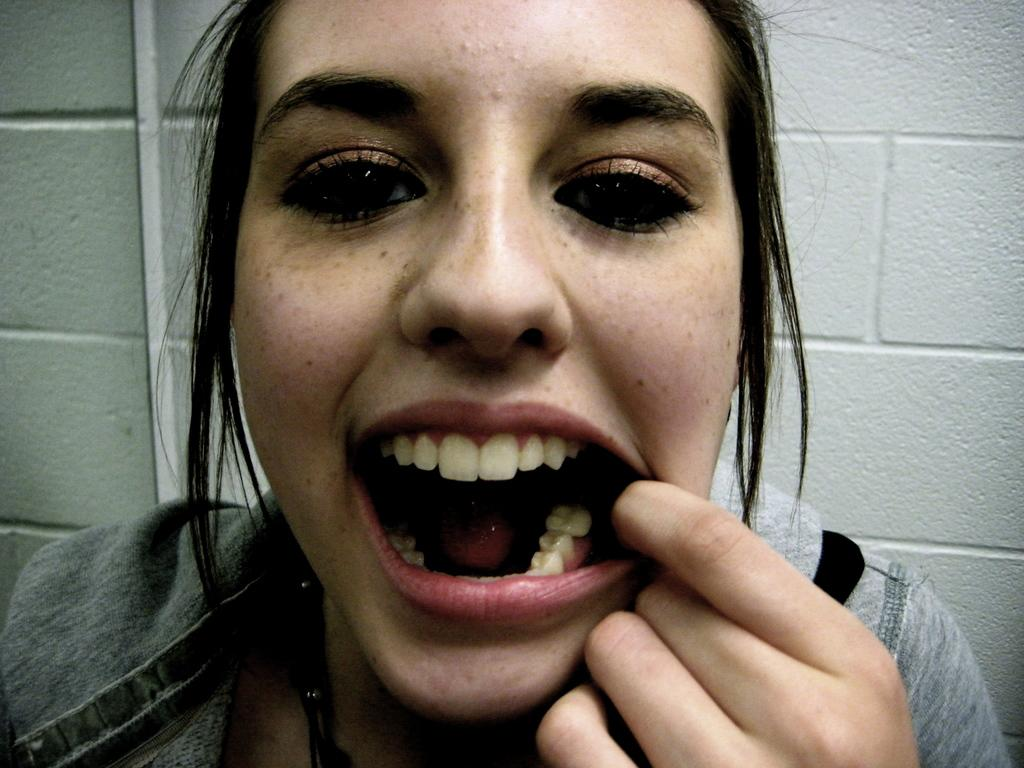Who is the main subject in the image? There is a lady in the image. What is the lady wearing in the image? The lady is wearing black threads. What type of accessory can be seen on the lady's neck? The lady has pearls on her neck. What is visible in the background of the image? There is a wall in the background of the image. What type of weather can be seen in the image? The image does not provide any information about the weather; it only shows the lady and the wall in the background. How does the lady's memory affect her appearance in the image? The image does not provide any information about the lady's memory or how it might affect her appearance. 